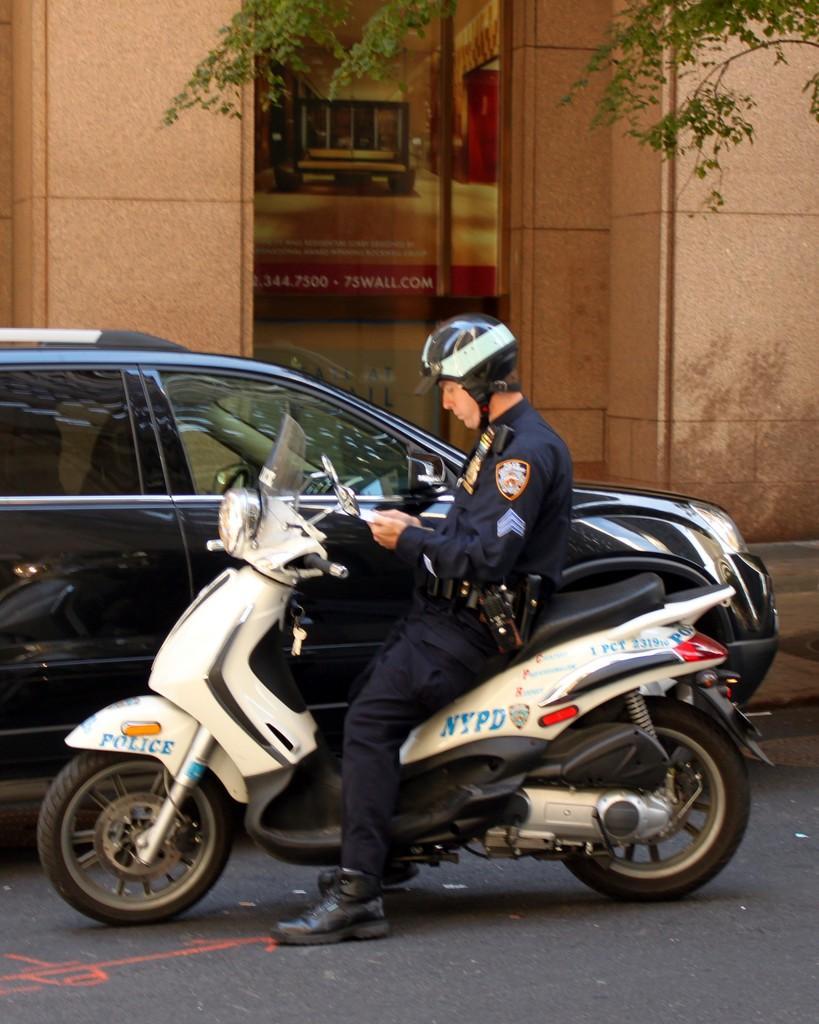Please provide a concise description of this image. In the image we can see a man wearing clothes, shoes, a helmet and he is sitting on the two wheeler. Beside him there is a car on the road. There is a building and the leaves. 